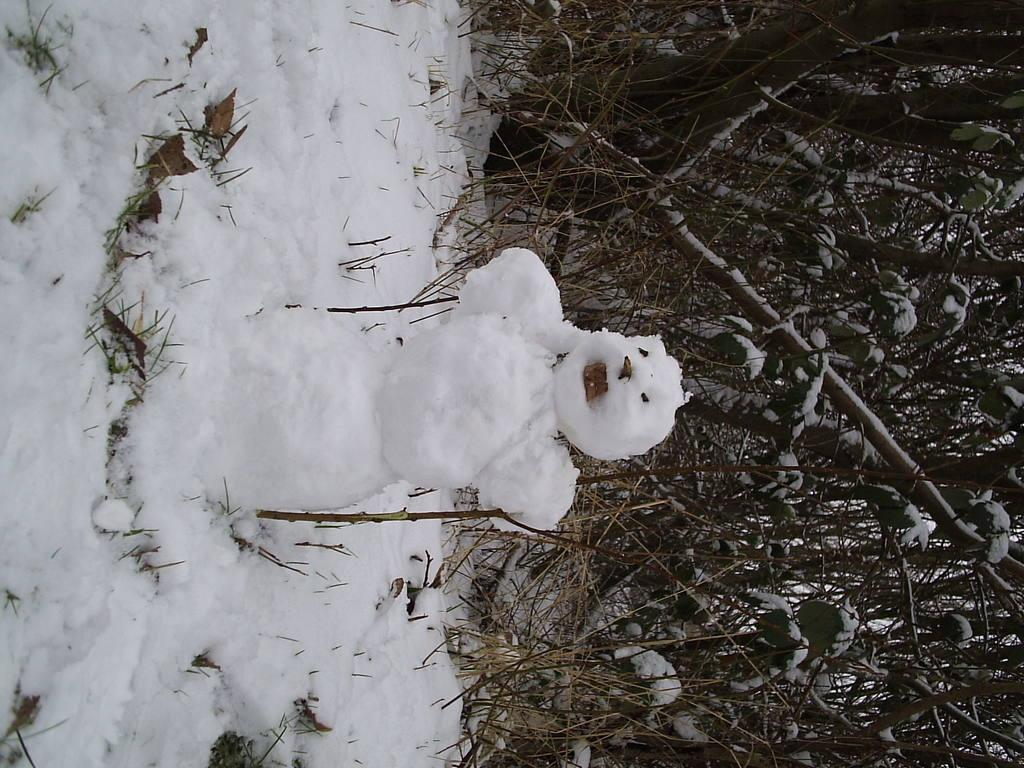What is the main subject of the image? There is a snowman in the image. What type of weather is depicted in the image? There is snow in the image. What type of natural environment is visible in the image? There are trees in the image. What type of pest can be seen crawling on the snowman in the image? There are no pests visible in the image; it features a snowman and trees in a snowy environment. How many houses are visible in the image? There are no houses present in the image; it features a snowman, snow, and trees. 